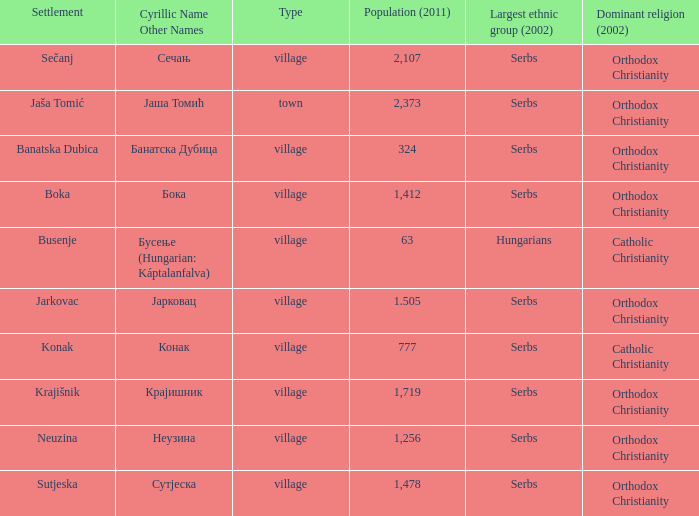The pooulation of јарковац is? 1.505. 